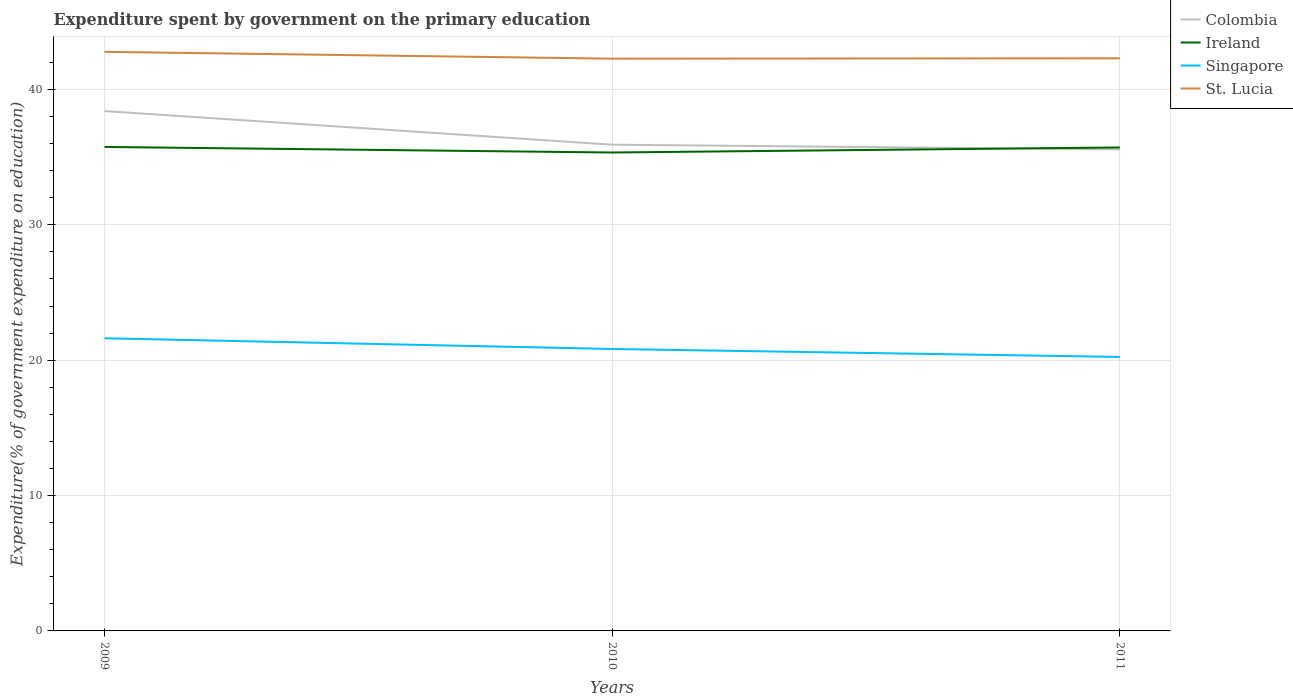Does the line corresponding to Colombia intersect with the line corresponding to Ireland?
Your answer should be very brief. Yes. Is the number of lines equal to the number of legend labels?
Ensure brevity in your answer.  Yes. Across all years, what is the maximum expenditure spent by government on the primary education in Singapore?
Provide a short and direct response. 20.24. In which year was the expenditure spent by government on the primary education in Ireland maximum?
Keep it short and to the point. 2010. What is the total expenditure spent by government on the primary education in Ireland in the graph?
Your answer should be compact. 0.04. What is the difference between the highest and the second highest expenditure spent by government on the primary education in Ireland?
Provide a short and direct response. 0.41. What is the difference between the highest and the lowest expenditure spent by government on the primary education in Colombia?
Ensure brevity in your answer.  1. How many years are there in the graph?
Give a very brief answer. 3. Does the graph contain any zero values?
Provide a short and direct response. No. Where does the legend appear in the graph?
Your response must be concise. Top right. How many legend labels are there?
Offer a terse response. 4. How are the legend labels stacked?
Provide a succinct answer. Vertical. What is the title of the graph?
Offer a very short reply. Expenditure spent by government on the primary education. What is the label or title of the Y-axis?
Give a very brief answer. Expenditure(% of government expenditure on education). What is the Expenditure(% of government expenditure on education) of Colombia in 2009?
Provide a succinct answer. 38.41. What is the Expenditure(% of government expenditure on education) of Ireland in 2009?
Offer a terse response. 35.75. What is the Expenditure(% of government expenditure on education) of Singapore in 2009?
Ensure brevity in your answer.  21.62. What is the Expenditure(% of government expenditure on education) of St. Lucia in 2009?
Offer a very short reply. 42.78. What is the Expenditure(% of government expenditure on education) of Colombia in 2010?
Give a very brief answer. 35.92. What is the Expenditure(% of government expenditure on education) of Ireland in 2010?
Offer a very short reply. 35.35. What is the Expenditure(% of government expenditure on education) in Singapore in 2010?
Provide a short and direct response. 20.83. What is the Expenditure(% of government expenditure on education) of St. Lucia in 2010?
Provide a short and direct response. 42.28. What is the Expenditure(% of government expenditure on education) in Colombia in 2011?
Your response must be concise. 35.58. What is the Expenditure(% of government expenditure on education) in Ireland in 2011?
Your response must be concise. 35.72. What is the Expenditure(% of government expenditure on education) in Singapore in 2011?
Keep it short and to the point. 20.24. What is the Expenditure(% of government expenditure on education) in St. Lucia in 2011?
Offer a very short reply. 42.3. Across all years, what is the maximum Expenditure(% of government expenditure on education) of Colombia?
Ensure brevity in your answer.  38.41. Across all years, what is the maximum Expenditure(% of government expenditure on education) in Ireland?
Your response must be concise. 35.75. Across all years, what is the maximum Expenditure(% of government expenditure on education) of Singapore?
Your answer should be compact. 21.62. Across all years, what is the maximum Expenditure(% of government expenditure on education) in St. Lucia?
Your answer should be very brief. 42.78. Across all years, what is the minimum Expenditure(% of government expenditure on education) in Colombia?
Ensure brevity in your answer.  35.58. Across all years, what is the minimum Expenditure(% of government expenditure on education) of Ireland?
Provide a succinct answer. 35.35. Across all years, what is the minimum Expenditure(% of government expenditure on education) in Singapore?
Offer a very short reply. 20.24. Across all years, what is the minimum Expenditure(% of government expenditure on education) of St. Lucia?
Offer a very short reply. 42.28. What is the total Expenditure(% of government expenditure on education) in Colombia in the graph?
Provide a short and direct response. 109.91. What is the total Expenditure(% of government expenditure on education) of Ireland in the graph?
Give a very brief answer. 106.82. What is the total Expenditure(% of government expenditure on education) in Singapore in the graph?
Provide a short and direct response. 62.69. What is the total Expenditure(% of government expenditure on education) in St. Lucia in the graph?
Offer a terse response. 127.37. What is the difference between the Expenditure(% of government expenditure on education) of Colombia in 2009 and that in 2010?
Give a very brief answer. 2.49. What is the difference between the Expenditure(% of government expenditure on education) in Ireland in 2009 and that in 2010?
Ensure brevity in your answer.  0.41. What is the difference between the Expenditure(% of government expenditure on education) of Singapore in 2009 and that in 2010?
Provide a short and direct response. 0.79. What is the difference between the Expenditure(% of government expenditure on education) in St. Lucia in 2009 and that in 2010?
Keep it short and to the point. 0.5. What is the difference between the Expenditure(% of government expenditure on education) in Colombia in 2009 and that in 2011?
Your response must be concise. 2.83. What is the difference between the Expenditure(% of government expenditure on education) in Ireland in 2009 and that in 2011?
Provide a short and direct response. 0.04. What is the difference between the Expenditure(% of government expenditure on education) of Singapore in 2009 and that in 2011?
Your answer should be compact. 1.38. What is the difference between the Expenditure(% of government expenditure on education) in St. Lucia in 2009 and that in 2011?
Provide a short and direct response. 0.48. What is the difference between the Expenditure(% of government expenditure on education) of Colombia in 2010 and that in 2011?
Give a very brief answer. 0.34. What is the difference between the Expenditure(% of government expenditure on education) of Ireland in 2010 and that in 2011?
Offer a terse response. -0.37. What is the difference between the Expenditure(% of government expenditure on education) of Singapore in 2010 and that in 2011?
Offer a terse response. 0.59. What is the difference between the Expenditure(% of government expenditure on education) in St. Lucia in 2010 and that in 2011?
Provide a succinct answer. -0.03. What is the difference between the Expenditure(% of government expenditure on education) of Colombia in 2009 and the Expenditure(% of government expenditure on education) of Ireland in 2010?
Make the answer very short. 3.06. What is the difference between the Expenditure(% of government expenditure on education) in Colombia in 2009 and the Expenditure(% of government expenditure on education) in Singapore in 2010?
Your answer should be compact. 17.58. What is the difference between the Expenditure(% of government expenditure on education) in Colombia in 2009 and the Expenditure(% of government expenditure on education) in St. Lucia in 2010?
Offer a terse response. -3.87. What is the difference between the Expenditure(% of government expenditure on education) of Ireland in 2009 and the Expenditure(% of government expenditure on education) of Singapore in 2010?
Your response must be concise. 14.92. What is the difference between the Expenditure(% of government expenditure on education) in Ireland in 2009 and the Expenditure(% of government expenditure on education) in St. Lucia in 2010?
Ensure brevity in your answer.  -6.52. What is the difference between the Expenditure(% of government expenditure on education) in Singapore in 2009 and the Expenditure(% of government expenditure on education) in St. Lucia in 2010?
Your answer should be compact. -20.66. What is the difference between the Expenditure(% of government expenditure on education) in Colombia in 2009 and the Expenditure(% of government expenditure on education) in Ireland in 2011?
Keep it short and to the point. 2.69. What is the difference between the Expenditure(% of government expenditure on education) in Colombia in 2009 and the Expenditure(% of government expenditure on education) in Singapore in 2011?
Provide a succinct answer. 18.16. What is the difference between the Expenditure(% of government expenditure on education) of Colombia in 2009 and the Expenditure(% of government expenditure on education) of St. Lucia in 2011?
Keep it short and to the point. -3.9. What is the difference between the Expenditure(% of government expenditure on education) of Ireland in 2009 and the Expenditure(% of government expenditure on education) of Singapore in 2011?
Your answer should be very brief. 15.51. What is the difference between the Expenditure(% of government expenditure on education) of Ireland in 2009 and the Expenditure(% of government expenditure on education) of St. Lucia in 2011?
Give a very brief answer. -6.55. What is the difference between the Expenditure(% of government expenditure on education) in Singapore in 2009 and the Expenditure(% of government expenditure on education) in St. Lucia in 2011?
Provide a succinct answer. -20.68. What is the difference between the Expenditure(% of government expenditure on education) in Colombia in 2010 and the Expenditure(% of government expenditure on education) in Ireland in 2011?
Provide a succinct answer. 0.2. What is the difference between the Expenditure(% of government expenditure on education) of Colombia in 2010 and the Expenditure(% of government expenditure on education) of Singapore in 2011?
Your answer should be compact. 15.68. What is the difference between the Expenditure(% of government expenditure on education) of Colombia in 2010 and the Expenditure(% of government expenditure on education) of St. Lucia in 2011?
Keep it short and to the point. -6.38. What is the difference between the Expenditure(% of government expenditure on education) of Ireland in 2010 and the Expenditure(% of government expenditure on education) of Singapore in 2011?
Keep it short and to the point. 15.1. What is the difference between the Expenditure(% of government expenditure on education) of Ireland in 2010 and the Expenditure(% of government expenditure on education) of St. Lucia in 2011?
Your answer should be compact. -6.96. What is the difference between the Expenditure(% of government expenditure on education) of Singapore in 2010 and the Expenditure(% of government expenditure on education) of St. Lucia in 2011?
Make the answer very short. -21.47. What is the average Expenditure(% of government expenditure on education) of Colombia per year?
Ensure brevity in your answer.  36.64. What is the average Expenditure(% of government expenditure on education) of Ireland per year?
Ensure brevity in your answer.  35.61. What is the average Expenditure(% of government expenditure on education) of Singapore per year?
Offer a very short reply. 20.9. What is the average Expenditure(% of government expenditure on education) in St. Lucia per year?
Ensure brevity in your answer.  42.46. In the year 2009, what is the difference between the Expenditure(% of government expenditure on education) in Colombia and Expenditure(% of government expenditure on education) in Ireland?
Offer a terse response. 2.65. In the year 2009, what is the difference between the Expenditure(% of government expenditure on education) in Colombia and Expenditure(% of government expenditure on education) in Singapore?
Offer a very short reply. 16.78. In the year 2009, what is the difference between the Expenditure(% of government expenditure on education) of Colombia and Expenditure(% of government expenditure on education) of St. Lucia?
Your response must be concise. -4.38. In the year 2009, what is the difference between the Expenditure(% of government expenditure on education) in Ireland and Expenditure(% of government expenditure on education) in Singapore?
Provide a short and direct response. 14.13. In the year 2009, what is the difference between the Expenditure(% of government expenditure on education) of Ireland and Expenditure(% of government expenditure on education) of St. Lucia?
Offer a terse response. -7.03. In the year 2009, what is the difference between the Expenditure(% of government expenditure on education) of Singapore and Expenditure(% of government expenditure on education) of St. Lucia?
Your answer should be compact. -21.16. In the year 2010, what is the difference between the Expenditure(% of government expenditure on education) of Colombia and Expenditure(% of government expenditure on education) of Ireland?
Make the answer very short. 0.58. In the year 2010, what is the difference between the Expenditure(% of government expenditure on education) in Colombia and Expenditure(% of government expenditure on education) in Singapore?
Your answer should be compact. 15.09. In the year 2010, what is the difference between the Expenditure(% of government expenditure on education) in Colombia and Expenditure(% of government expenditure on education) in St. Lucia?
Make the answer very short. -6.36. In the year 2010, what is the difference between the Expenditure(% of government expenditure on education) of Ireland and Expenditure(% of government expenditure on education) of Singapore?
Provide a short and direct response. 14.52. In the year 2010, what is the difference between the Expenditure(% of government expenditure on education) of Ireland and Expenditure(% of government expenditure on education) of St. Lucia?
Ensure brevity in your answer.  -6.93. In the year 2010, what is the difference between the Expenditure(% of government expenditure on education) of Singapore and Expenditure(% of government expenditure on education) of St. Lucia?
Your answer should be very brief. -21.45. In the year 2011, what is the difference between the Expenditure(% of government expenditure on education) of Colombia and Expenditure(% of government expenditure on education) of Ireland?
Provide a short and direct response. -0.14. In the year 2011, what is the difference between the Expenditure(% of government expenditure on education) in Colombia and Expenditure(% of government expenditure on education) in Singapore?
Offer a very short reply. 15.33. In the year 2011, what is the difference between the Expenditure(% of government expenditure on education) in Colombia and Expenditure(% of government expenditure on education) in St. Lucia?
Your answer should be compact. -6.73. In the year 2011, what is the difference between the Expenditure(% of government expenditure on education) of Ireland and Expenditure(% of government expenditure on education) of Singapore?
Ensure brevity in your answer.  15.48. In the year 2011, what is the difference between the Expenditure(% of government expenditure on education) of Ireland and Expenditure(% of government expenditure on education) of St. Lucia?
Offer a very short reply. -6.59. In the year 2011, what is the difference between the Expenditure(% of government expenditure on education) of Singapore and Expenditure(% of government expenditure on education) of St. Lucia?
Your response must be concise. -22.06. What is the ratio of the Expenditure(% of government expenditure on education) in Colombia in 2009 to that in 2010?
Your response must be concise. 1.07. What is the ratio of the Expenditure(% of government expenditure on education) of Ireland in 2009 to that in 2010?
Provide a succinct answer. 1.01. What is the ratio of the Expenditure(% of government expenditure on education) of Singapore in 2009 to that in 2010?
Your response must be concise. 1.04. What is the ratio of the Expenditure(% of government expenditure on education) of St. Lucia in 2009 to that in 2010?
Make the answer very short. 1.01. What is the ratio of the Expenditure(% of government expenditure on education) in Colombia in 2009 to that in 2011?
Ensure brevity in your answer.  1.08. What is the ratio of the Expenditure(% of government expenditure on education) in Ireland in 2009 to that in 2011?
Ensure brevity in your answer.  1. What is the ratio of the Expenditure(% of government expenditure on education) in Singapore in 2009 to that in 2011?
Your response must be concise. 1.07. What is the ratio of the Expenditure(% of government expenditure on education) in St. Lucia in 2009 to that in 2011?
Provide a short and direct response. 1.01. What is the ratio of the Expenditure(% of government expenditure on education) of Colombia in 2010 to that in 2011?
Provide a succinct answer. 1.01. What is the ratio of the Expenditure(% of government expenditure on education) in Singapore in 2010 to that in 2011?
Ensure brevity in your answer.  1.03. What is the ratio of the Expenditure(% of government expenditure on education) of St. Lucia in 2010 to that in 2011?
Keep it short and to the point. 1. What is the difference between the highest and the second highest Expenditure(% of government expenditure on education) in Colombia?
Provide a succinct answer. 2.49. What is the difference between the highest and the second highest Expenditure(% of government expenditure on education) of Ireland?
Make the answer very short. 0.04. What is the difference between the highest and the second highest Expenditure(% of government expenditure on education) of Singapore?
Your answer should be compact. 0.79. What is the difference between the highest and the second highest Expenditure(% of government expenditure on education) of St. Lucia?
Offer a terse response. 0.48. What is the difference between the highest and the lowest Expenditure(% of government expenditure on education) of Colombia?
Give a very brief answer. 2.83. What is the difference between the highest and the lowest Expenditure(% of government expenditure on education) of Ireland?
Your response must be concise. 0.41. What is the difference between the highest and the lowest Expenditure(% of government expenditure on education) of Singapore?
Offer a terse response. 1.38. What is the difference between the highest and the lowest Expenditure(% of government expenditure on education) in St. Lucia?
Offer a very short reply. 0.5. 